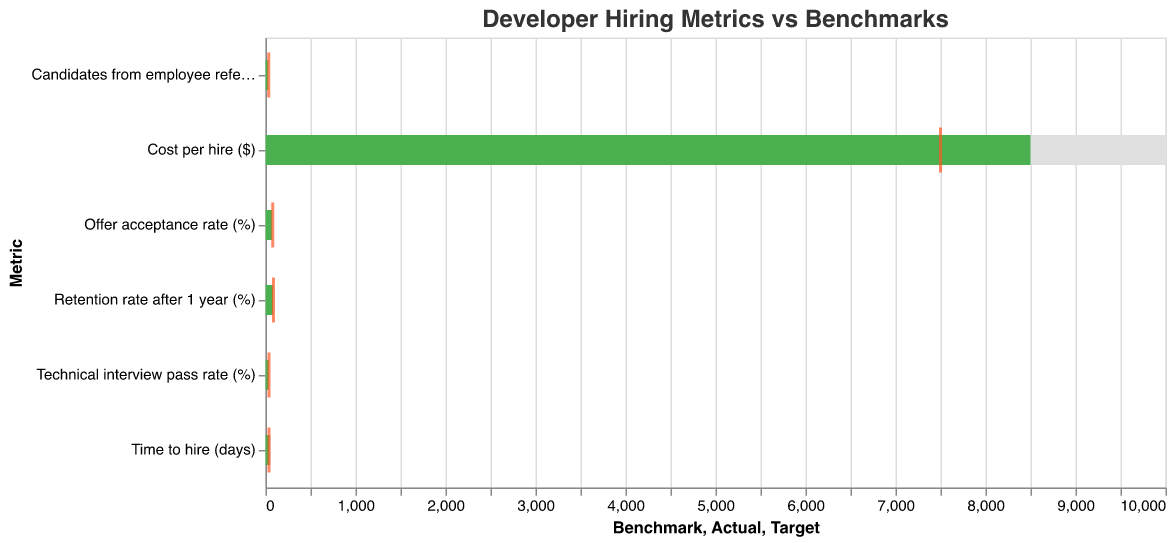What is the actual time to hire for developers? The actual time to hire for developers is directly shown as a bar in the figure, corresponding to the "Time to hire (days)" metric.
Answer: 45 days How does the offer acceptance rate compare to the benchmark? To compare the offer acceptance rate to the benchmark, look at both bars for the "Offer acceptance rate (%)" metric. The actual rate (75%) is higher than the benchmark (70%).
Answer: The actual rate is 5% higher than the benchmark What is the difference between the actual and target retention rate after one year? Subtract the target retention rate (90%) from the actual retention rate (85%) to find the difference.
Answer: The difference is -5% Which metric has the greatest discrepancy between actual and target values? Calculate the absolute differences for each metric between the actual and target values: Time to hire (5), Offer acceptance rate (5), Technical interview pass rate (5), Retention rate after one year (5), Cost per hire (1000), Candidates from employee referrals (5). The largest discrepancy is for "Cost per hire".
Answer: Cost per hire Are there any metrics where the actual value exceeds both the benchmark and the target? Examine all the metrics and compare each actual value to its corresponding benchmark and target. None of the actual values exceed both the benchmark and the target.
Answer: No What is the benchmark value for cost per hire, and how does it compare to the actual cost? The benchmark value for cost per hire is shown by the grey bar for the "Cost per hire ($)" metric, at $10,000, and the actual cost represented by the green bar is $8,500, which is lower.
Answer: The benchmark is $10,000, and the actual cost is $1,500 lower Which metric has the closest alignment between actual and target values? Calculate the absolute differences between actual and target values for each metric. The smallest difference is 5, found in "Time to hire (days)", "Offer acceptance rate (%)", "Technical interview pass rate (%)", "Retention rate after 1 year (%)", and "Candidates from employee referrals (%)". Since all these metrics have the same smallest difference, any of them could be the closest alignment.
Answer: Multiple metrics align closely In which metric is the performance significantly better than the benchmark, but still below the target? For each metric, identify if the actual value is higher than the benchmark and lower than the target. This is true for "Offer acceptance rate (%)", "Technical interview pass rate (%)", "Retention rate after 1 year (%)", and "Candidates from employee referrals (%)".
Answer: Multiple metrics show this pattern How much lower is the actual cost per hire compared to the target cost? Subtract the actual cost per hire ($8,500) from the target cost per hire ($7,500).
Answer: $1,000 higher 